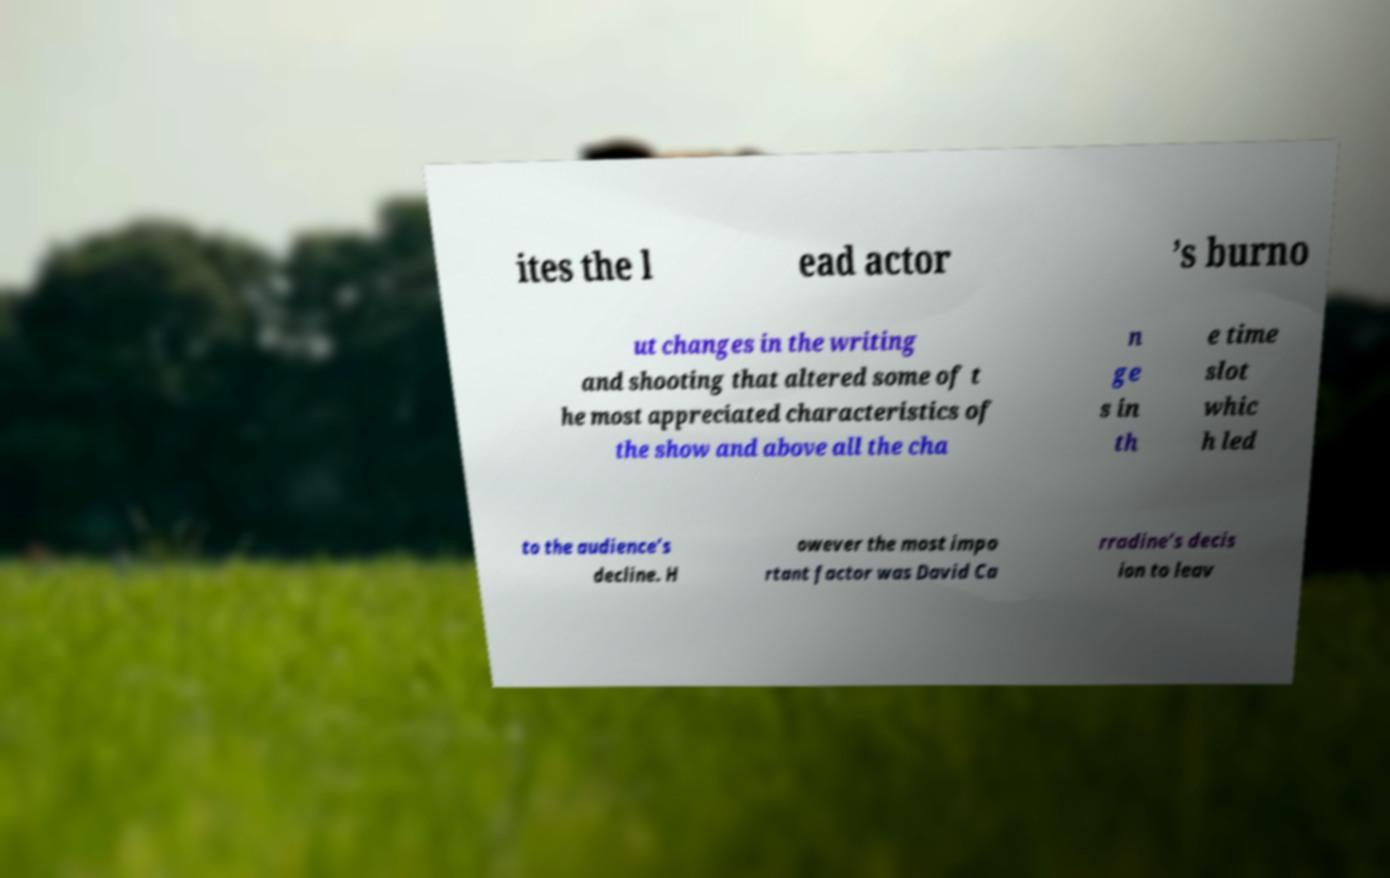What messages or text are displayed in this image? I need them in a readable, typed format. ites the l ead actor ’s burno ut changes in the writing and shooting that altered some of t he most appreciated characteristics of the show and above all the cha n ge s in th e time slot whic h led to the audience’s decline. H owever the most impo rtant factor was David Ca rradine’s decis ion to leav 